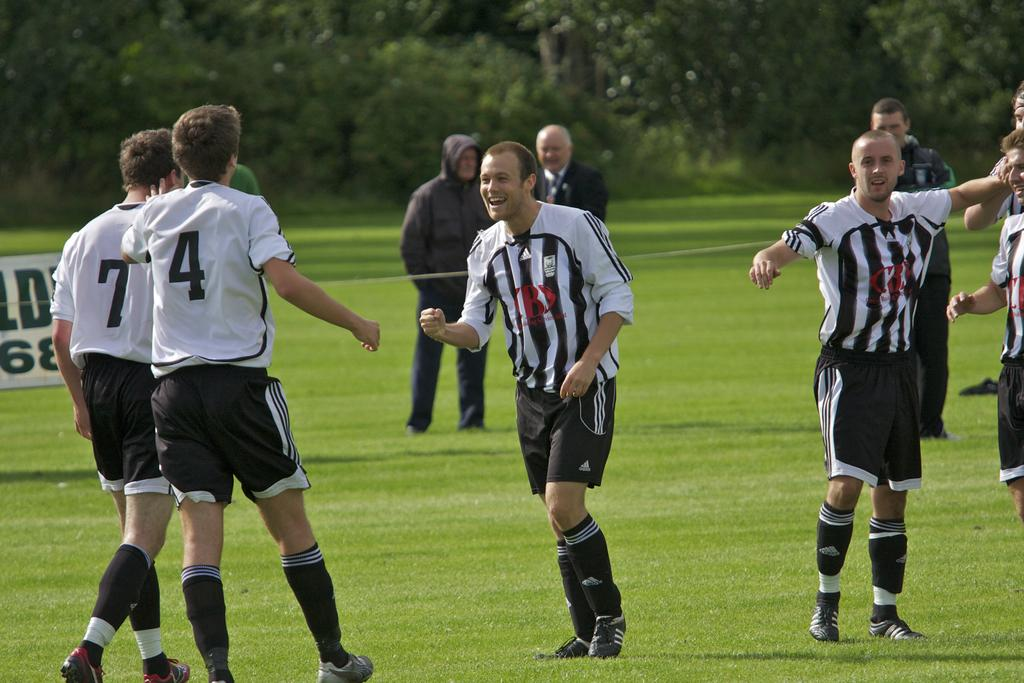Who or what is present in the image? There are people in the image. What object can be seen in the image? There is a board in the image. What type of natural environment is visible in the background? There are trees in the background of the image. What type of ground is visible at the bottom of the image? There is grass at the bottom of the image. How many brothers are playing with the lead in the image? There is no lead or brothers present in the image. 